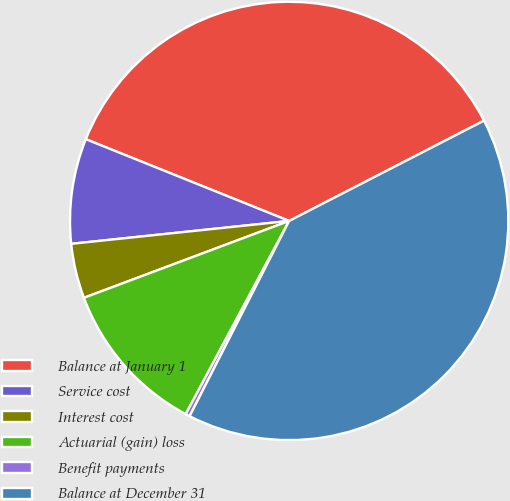<chart> <loc_0><loc_0><loc_500><loc_500><pie_chart><fcel>Balance at January 1<fcel>Service cost<fcel>Interest cost<fcel>Actuarial (gain) loss<fcel>Benefit payments<fcel>Balance at December 31<nl><fcel>36.35%<fcel>7.75%<fcel>4.04%<fcel>11.47%<fcel>0.32%<fcel>40.07%<nl></chart> 